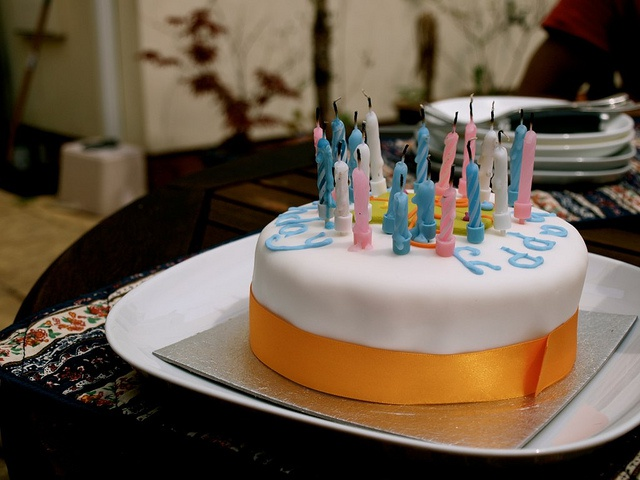Describe the objects in this image and their specific colors. I can see dining table in black, darkgray, lightgray, and brown tones, cake in black, darkgray, lightgray, red, and orange tones, knife in black, gray, and darkgray tones, fork in black, gray, and darkgray tones, and spoon in black, gray, and darkgray tones in this image. 